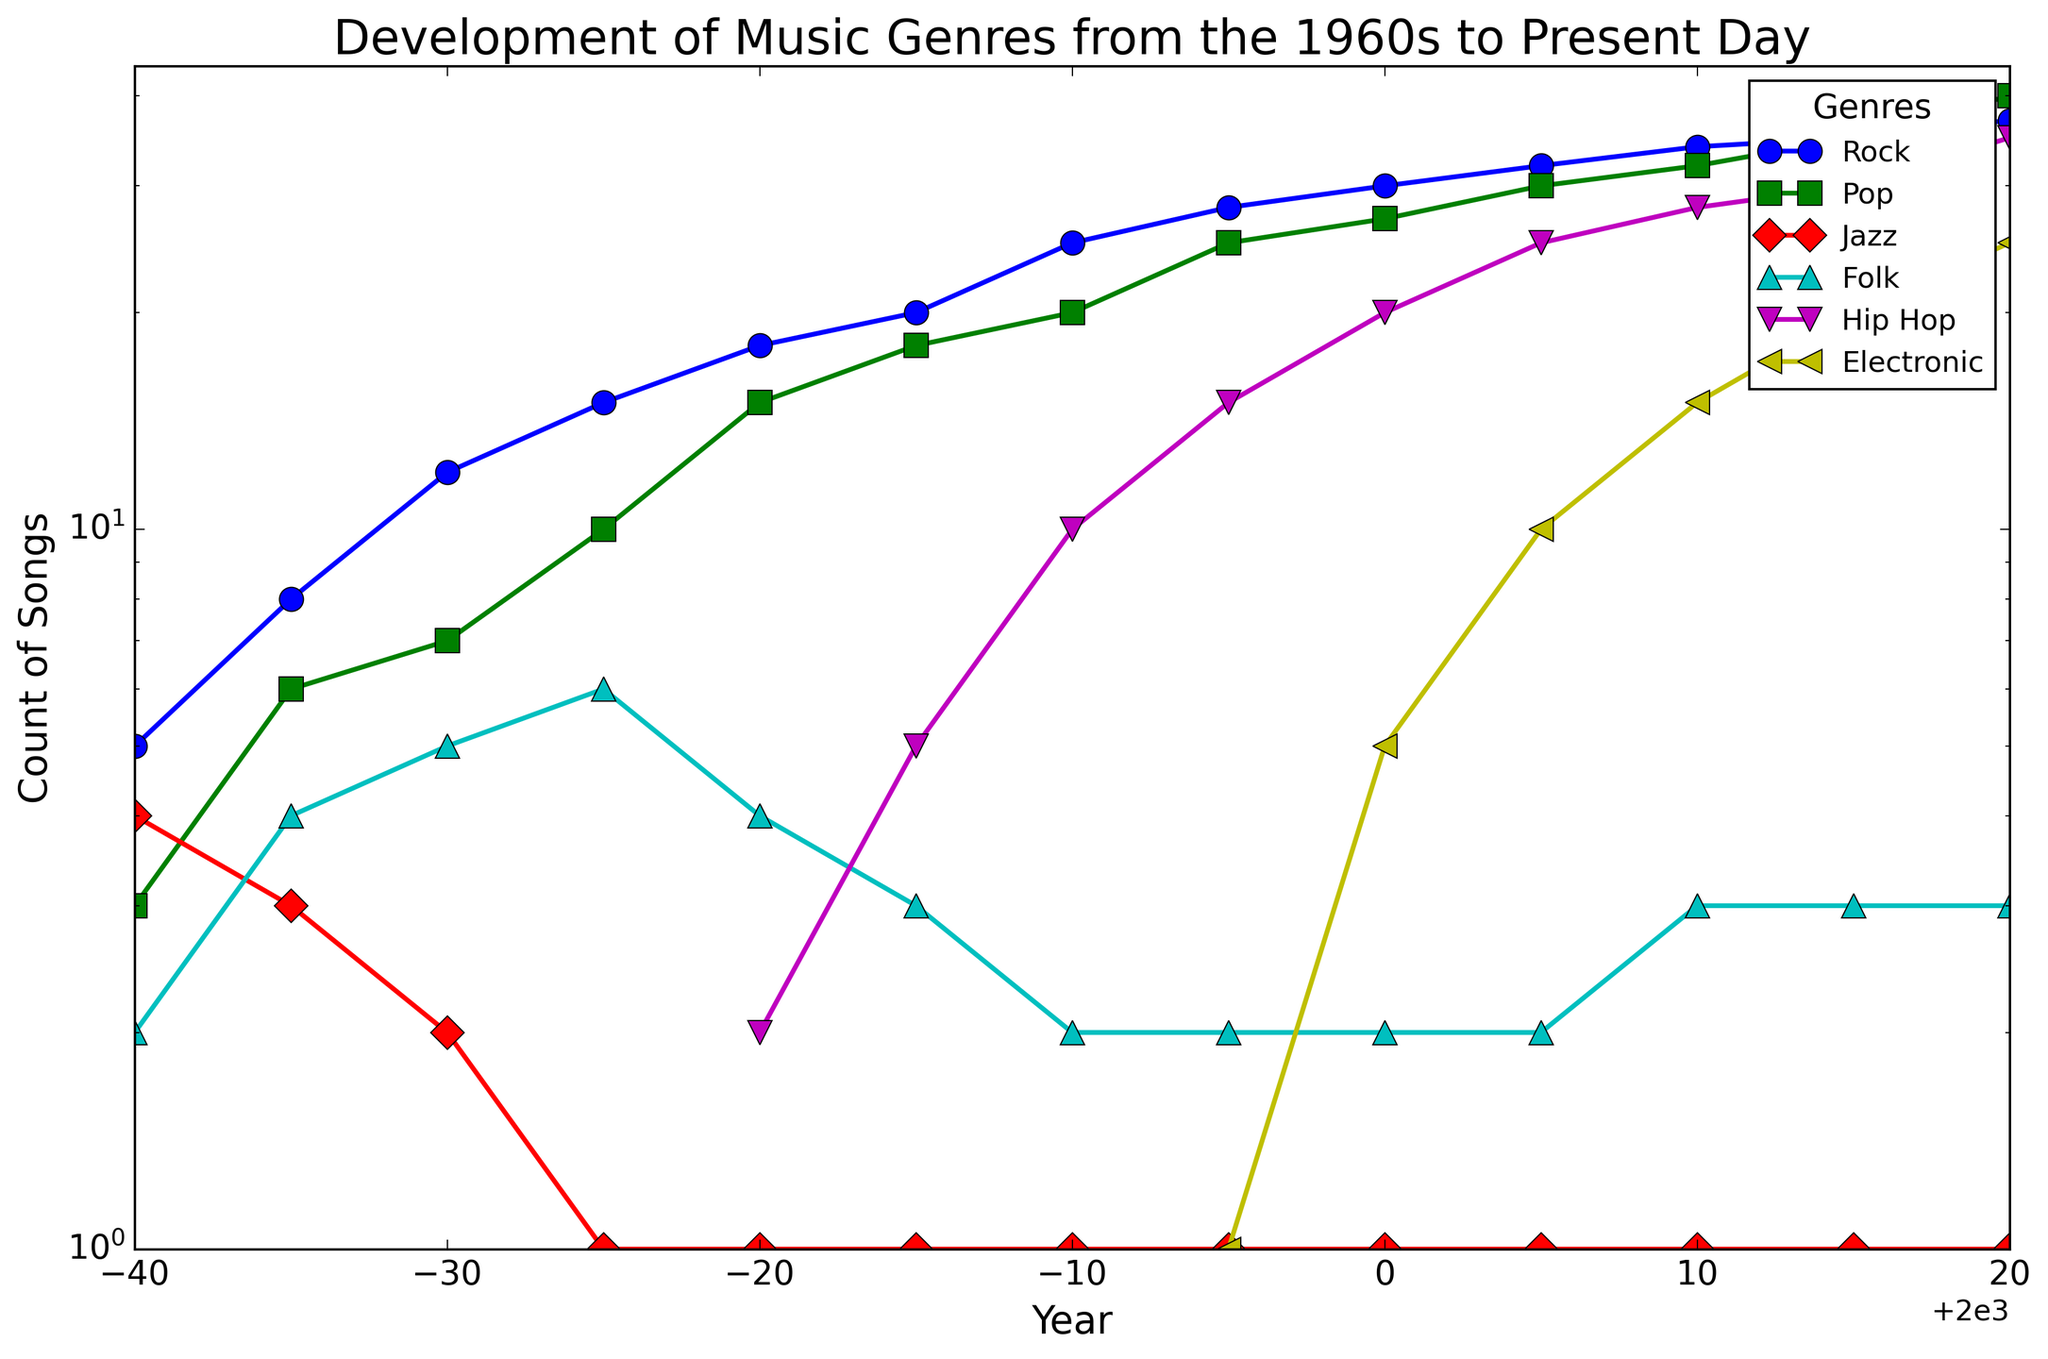In which year did Hip Hop surpass Folk in terms of song count? Hip Hop first appears in 1980 with 2 songs, while Folk has 4. Over the years, Hip Hop increases faster. By 1985, Hip Hop has 5 songs, surpassing Folk's 3.
Answer: 1985 What is the most popular genre in 2020? Look at the counts in 2020. The genre with the highest count is Pop with 40 songs.
Answer: Pop Compare the counts of Rock and Jazz in 1975. How many more songs does Rock have compared to Jazz? In 1975, Rock has 15 songs and Jazz has 1 song. The difference is 15 - 1 = 14.
Answer: 14 Which genre showed the largest growth from 1980 to 2020? Calculate the growth for each genre between 1980 and 2020. Hip Hop grows from 2 to 35 (33) while others grow less: Rock (19), Pop (25), Jazz (0), Folk (-1), Electronic (25). Hip Hop has the largest increase.
Answer: Hip Hop By how many songs did Pop surpass Rock in 2015? In 2015, Pop has 35 songs compared to Rock’s 35. The difference is 35 - 35 = 0.
Answer: 0 Which genres had a constant number of songs from 1975 onwards? Only Jazz has a constant count of 1 song from 1975 to 2020, while others change over the years.
Answer: Jazz In what year did Electronic music exceed 10 songs for the first time? Electronic music had 10 songs in 2005 and first exceeded that number in 2010 with 15 songs.
Answer: 2010 Compare the song counts of Folk in 1960 and 2020. Has the number increased or decreased, and by how much? In 1960, Folk had 2 songs. In 2020, it had 3 songs. The increase is 3 - 2 = 1.
Answer: Increased by 1 How many genres had more than 25 songs in 2020? In 2020, Rock, Pop, Hip Hop, and Electronic all had more than 25 songs: 37, 40, 35, and 25 respectively.
Answer: 3 